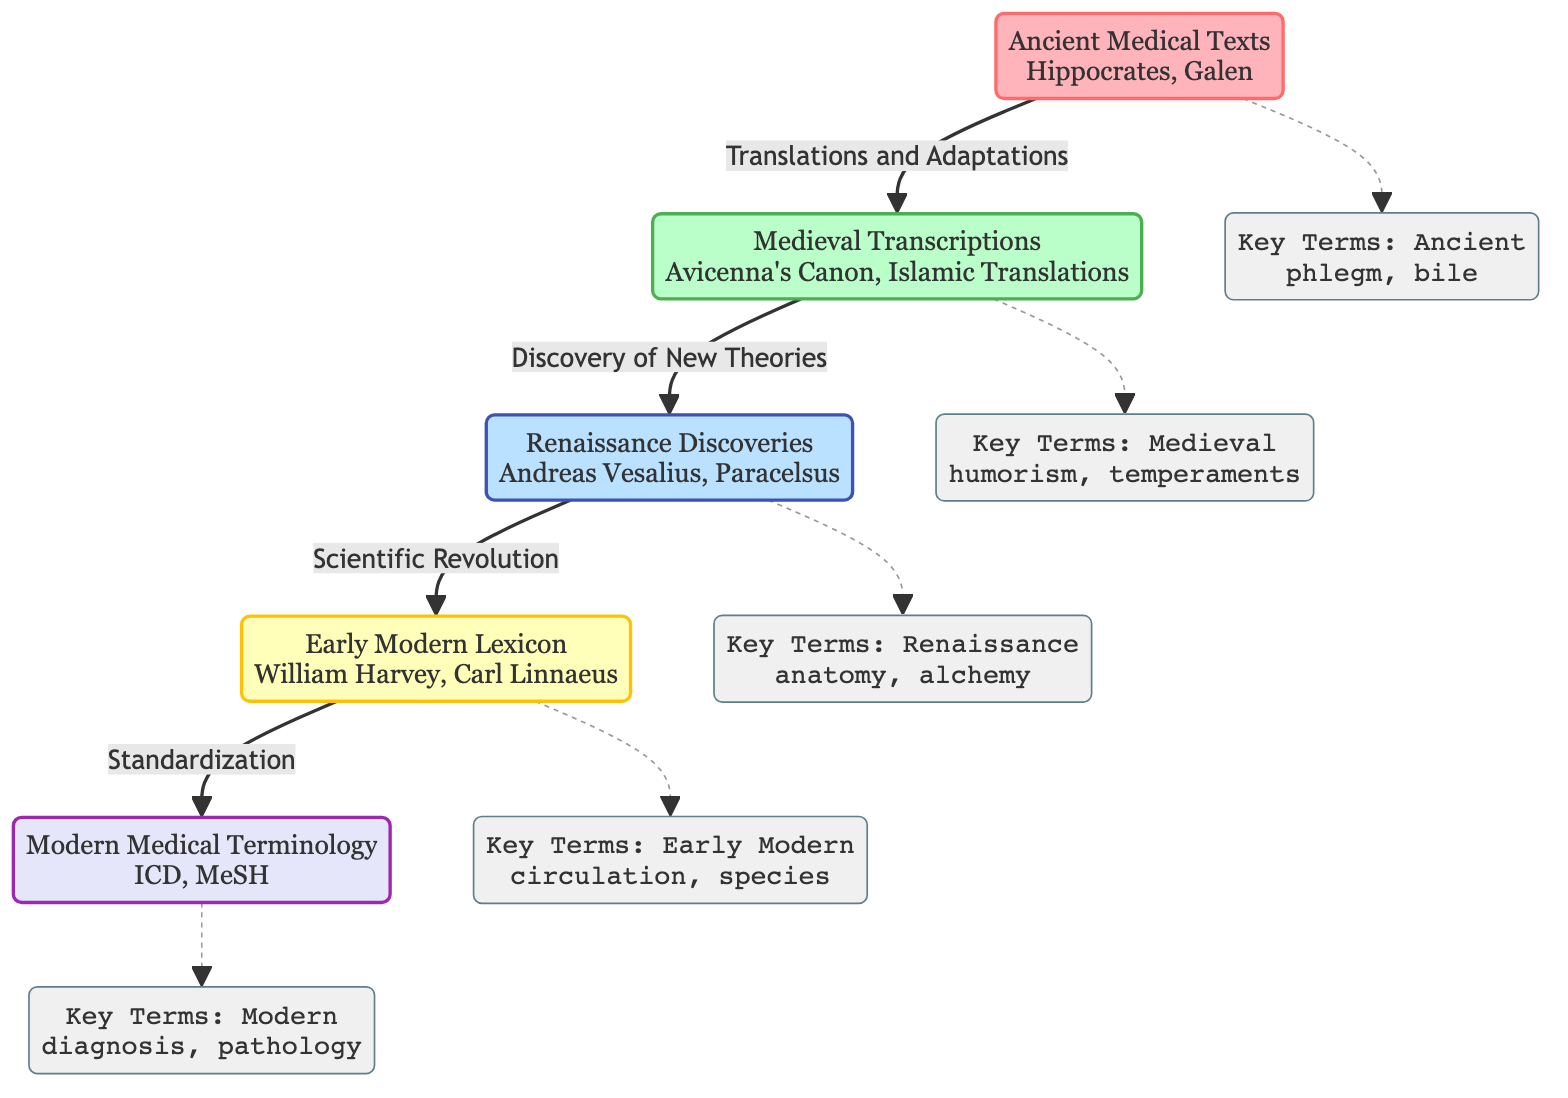What is the earliest period represented in the diagram? The diagram indicates that the earliest period is "Ancient Medical Texts," specifically referencing Hippocrates and Galen. This information is located at the first node of the flowchart, establishing the starting point of the evolution of medical terminology.
Answer: Ancient Medical Texts Which term is associated with the Medieval period? The Medieval period is linked to the term "humorism," which is listed under the "Key Terms: Medieval" node. This node connects to the Medieval Transcriptions section in the diagram, reflecting a specific aspect of that period's medical terminology.
Answer: humorism How many key terms are categorized under the Renaissance? The Renaissance period includes "anatomy" and "alchemy" as its key terms, making a total of 2 key terms represented in this section of the diagram. This information is directly provided in the "Key Terms: Renaissance" node.
Answer: 2 What significant shift occurs after the Renaissance period? The diagram shows that the significant shift after the Renaissance is characterized by the "Scientific Revolution," which leads to the Early Modern Lexicon. The connection between the Renaissance and Early Modern stages indicates this transformation.
Answer: Scientific Revolution What modern entities are included in the last section of the diagram? The last section of the diagram presents modern entities, specifically listing "ICD" and "MeSH." This is found under the "Modern Medical Terminology" node, reflecting contemporary terminologies in the medical field.
Answer: ICD, MeSH Which key term appears under Early Modern terminology? Under the Early Modern terminology node, the key term listed is "circulation." This appears within the "Key Terms: Early Modern" node, showcasing an important concept from this timeframe in the evolution of medical terminology.
Answer: circulation What type of relationship connects the Ancient and Medieval periods? The relationship connecting the Ancient and Medieval periods is described as "Translations and Adaptations." This specific link is depicted in the diagram, showing how medical terminology evolved through translation efforts from ancient texts to medieval understandings.
Answer: Translations and Adaptations What is the color representing the Medieval period in this diagram? The Medieval period is represented by a greenish color, specifically referenced in the diagram with the class definition for the medieval node displaying shades of green (BAFFC9). The specific color code reflects the visual representation of this historical segment in the flowchart.
Answer: greenish 